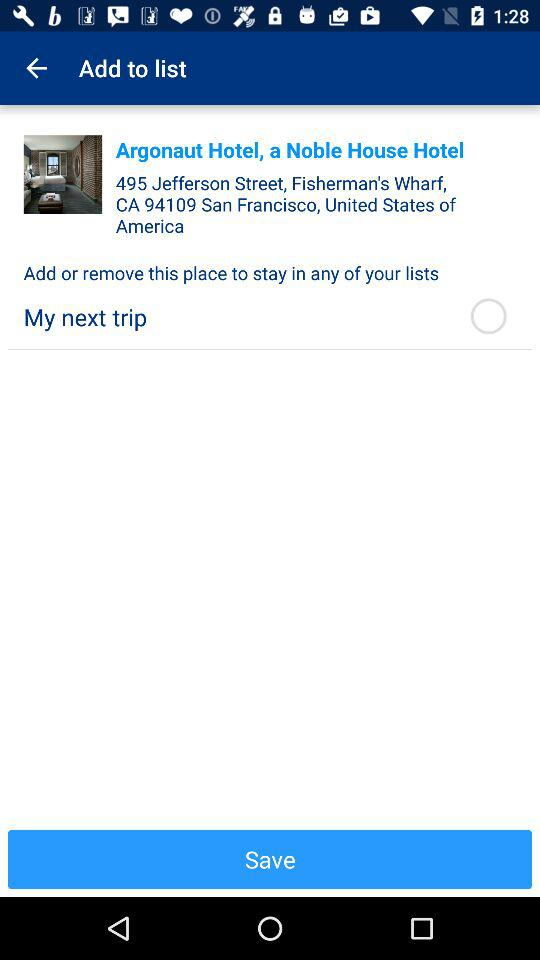What is the location of the Argonaut Hotel? The location is 495 Jefferson Street, Fisherman's Wharf, CA 94109, San Francisco, United States of America. 